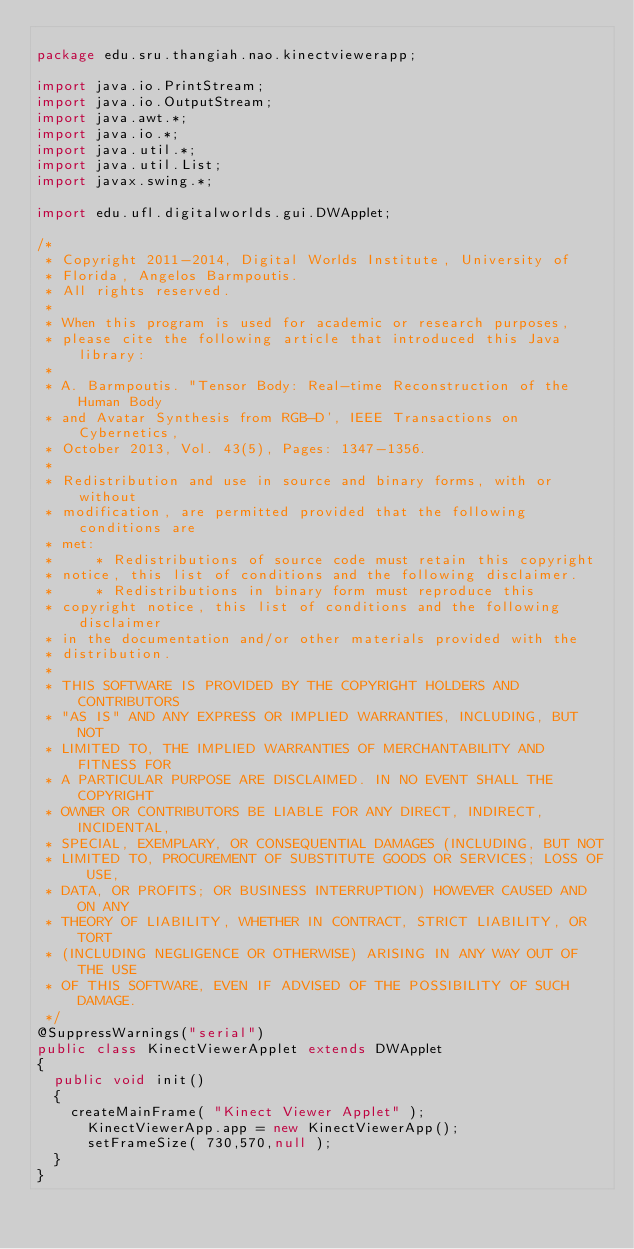<code> <loc_0><loc_0><loc_500><loc_500><_Java_>
package edu.sru.thangiah.nao.kinectviewerapp;

import java.io.PrintStream;
import java.io.OutputStream;
import java.awt.*;
import java.io.*;
import java.util.*;
import java.util.List;
import javax.swing.*;

import edu.ufl.digitalworlds.gui.DWApplet;

/*
 * Copyright 2011-2014, Digital Worlds Institute, University of 
 * Florida, Angelos Barmpoutis.
 * All rights reserved.
 *
 * When this program is used for academic or research purposes, 
 * please cite the following article that introduced this Java library: 
 * 
 * A. Barmpoutis. "Tensor Body: Real-time Reconstruction of the Human Body 
 * and Avatar Synthesis from RGB-D', IEEE Transactions on Cybernetics, 
 * October 2013, Vol. 43(5), Pages: 1347-1356. 
 * 
 * Redistribution and use in source and binary forms, with or without
 * modification, are permitted provided that the following conditions are
 * met:
 *     * Redistributions of source code must retain this copyright
 * notice, this list of conditions and the following disclaimer.
 *     * Redistributions in binary form must reproduce this
 * copyright notice, this list of conditions and the following disclaimer
 * in the documentation and/or other materials provided with the
 * distribution.
 * 
 * THIS SOFTWARE IS PROVIDED BY THE COPYRIGHT HOLDERS AND CONTRIBUTORS
 * "AS IS" AND ANY EXPRESS OR IMPLIED WARRANTIES, INCLUDING, BUT NOT
 * LIMITED TO, THE IMPLIED WARRANTIES OF MERCHANTABILITY AND FITNESS FOR
 * A PARTICULAR PURPOSE ARE DISCLAIMED. IN NO EVENT SHALL THE COPYRIGHT
 * OWNER OR CONTRIBUTORS BE LIABLE FOR ANY DIRECT, INDIRECT, INCIDENTAL,
 * SPECIAL, EXEMPLARY, OR CONSEQUENTIAL DAMAGES (INCLUDING, BUT NOT
 * LIMITED TO, PROCUREMENT OF SUBSTITUTE GOODS OR SERVICES; LOSS OF USE,
 * DATA, OR PROFITS; OR BUSINESS INTERRUPTION) HOWEVER CAUSED AND ON ANY
 * THEORY OF LIABILITY, WHETHER IN CONTRACT, STRICT LIABILITY, OR TORT
 * (INCLUDING NEGLIGENCE OR OTHERWISE) ARISING IN ANY WAY OUT OF THE USE
 * OF THIS SOFTWARE, EVEN IF ADVISED OF THE POSSIBILITY OF SUCH DAMAGE.
 */
@SuppressWarnings("serial")
public class KinectViewerApplet extends DWApplet
{
	public void init()
	{
		createMainFrame( "Kinect Viewer Applet" );
    	KinectViewerApp.app = new KinectViewerApp();
    	setFrameSize( 730,570,null );
	}
}

</code> 